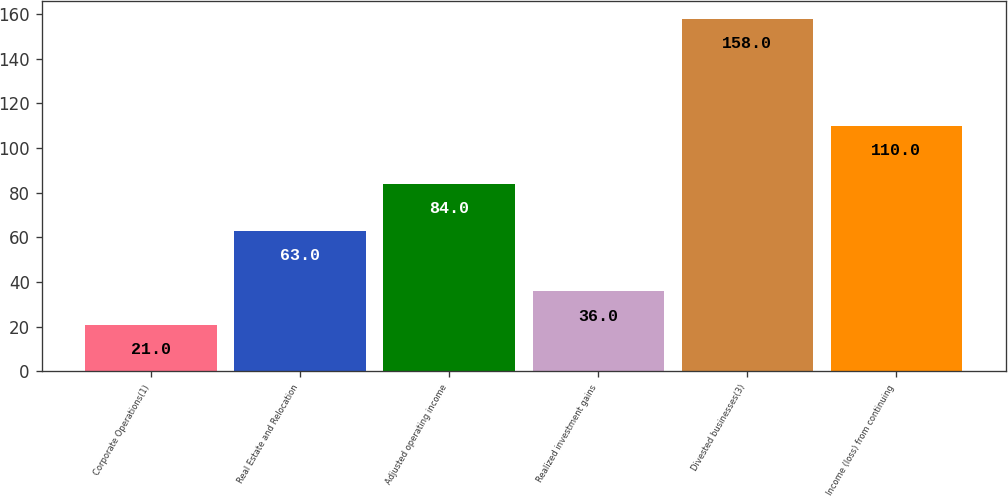Convert chart to OTSL. <chart><loc_0><loc_0><loc_500><loc_500><bar_chart><fcel>Corporate Operations(1)<fcel>Real Estate and Relocation<fcel>Adjusted operating income<fcel>Realized investment gains<fcel>Divested businesses(3)<fcel>Income (loss) from continuing<nl><fcel>21<fcel>63<fcel>84<fcel>36<fcel>158<fcel>110<nl></chart> 